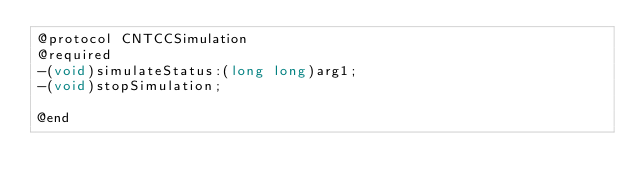<code> <loc_0><loc_0><loc_500><loc_500><_C_>@protocol CNTCCSimulation
@required
-(void)simulateStatus:(long long)arg1;
-(void)stopSimulation;

@end

</code> 